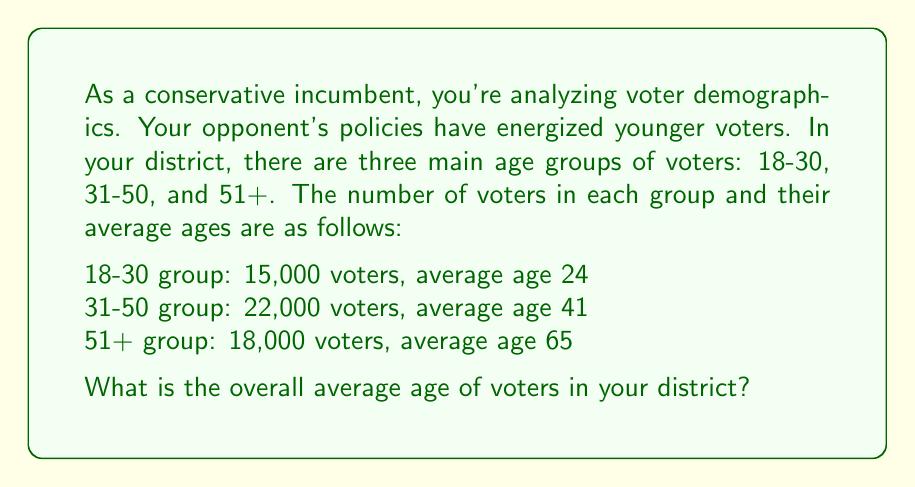Provide a solution to this math problem. To solve this problem, we need to use the weighted average formula. Here's the step-by-step process:

1. Calculate the total number of voters:
   $15,000 + 22,000 + 18,000 = 55,000$ total voters

2. For each group, multiply the number of voters by their average age:
   18-30 group: $15,000 \times 24 = 360,000$
   31-50 group: $22,000 \times 41 = 902,000$
   51+ group: $18,000 \times 65 = 1,170,000$

3. Sum up these products:
   $360,000 + 902,000 + 1,170,000 = 2,432,000$

4. Divide this sum by the total number of voters to get the weighted average:

   $$\text{Average Age} = \frac{2,432,000}{55,000} = 44.22$$

Therefore, the overall average age of voters in your district is approximately 44.22 years.
Answer: 44.22 years 